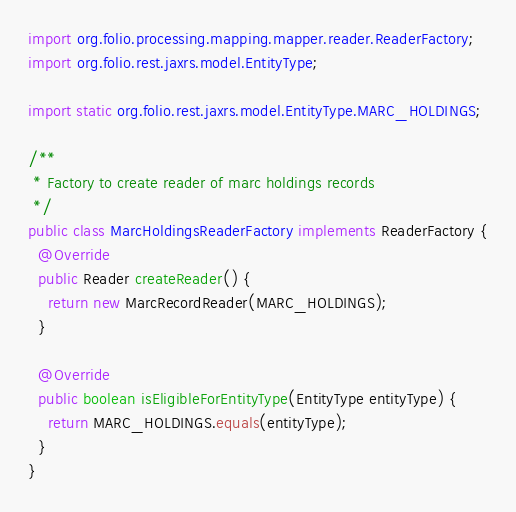Convert code to text. <code><loc_0><loc_0><loc_500><loc_500><_Java_>import org.folio.processing.mapping.mapper.reader.ReaderFactory;
import org.folio.rest.jaxrs.model.EntityType;

import static org.folio.rest.jaxrs.model.EntityType.MARC_HOLDINGS;

/**
 * Factory to create reader of marc holdings records
 */
public class MarcHoldingsReaderFactory implements ReaderFactory {
  @Override
  public Reader createReader() {
    return new MarcRecordReader(MARC_HOLDINGS);
  }

  @Override
  public boolean isEligibleForEntityType(EntityType entityType) {
    return MARC_HOLDINGS.equals(entityType);
  }
}
</code> 